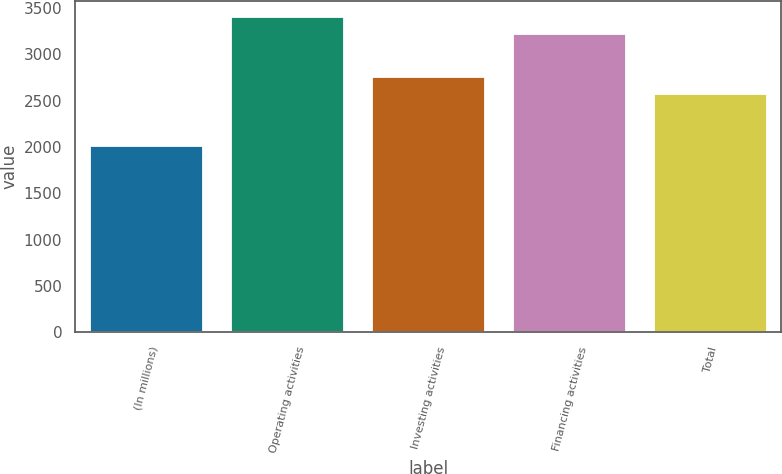<chart> <loc_0><loc_0><loc_500><loc_500><bar_chart><fcel>(In millions)<fcel>Operating activities<fcel>Investing activities<fcel>Financing activities<fcel>Total<nl><fcel>2013<fcel>3405<fcel>2756<fcel>3217<fcel>2568<nl></chart> 